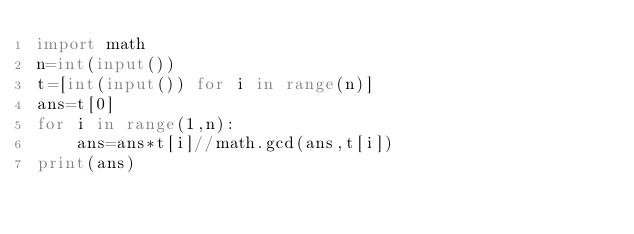<code> <loc_0><loc_0><loc_500><loc_500><_Python_>import math
n=int(input())
t=[int(input()) for i in range(n)]
ans=t[0]
for i in range(1,n):
    ans=ans*t[i]//math.gcd(ans,t[i])
print(ans)</code> 